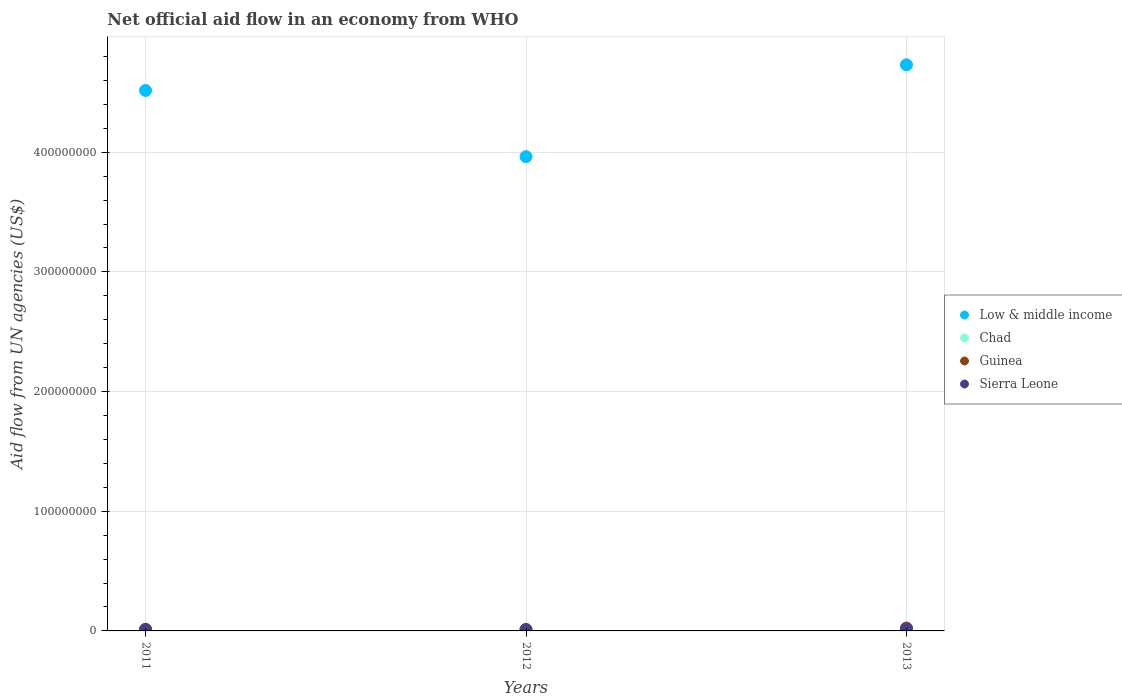Is the number of dotlines equal to the number of legend labels?
Make the answer very short. Yes. What is the net official aid flow in Chad in 2012?
Offer a very short reply. 1.04e+06. Across all years, what is the maximum net official aid flow in Chad?
Keep it short and to the point. 1.61e+06. Across all years, what is the minimum net official aid flow in Low & middle income?
Your answer should be very brief. 3.96e+08. In which year was the net official aid flow in Sierra Leone maximum?
Keep it short and to the point. 2013. In which year was the net official aid flow in Low & middle income minimum?
Keep it short and to the point. 2012. What is the total net official aid flow in Guinea in the graph?
Your response must be concise. 4.86e+06. What is the difference between the net official aid flow in Sierra Leone in 2012 and that in 2013?
Keep it short and to the point. -6.40e+05. What is the difference between the net official aid flow in Sierra Leone in 2011 and the net official aid flow in Low & middle income in 2012?
Make the answer very short. -3.95e+08. What is the average net official aid flow in Guinea per year?
Offer a very short reply. 1.62e+06. In the year 2012, what is the difference between the net official aid flow in Chad and net official aid flow in Guinea?
Keep it short and to the point. -2.30e+05. What is the ratio of the net official aid flow in Chad in 2011 to that in 2012?
Give a very brief answer. 1.51. Is the net official aid flow in Low & middle income in 2011 less than that in 2012?
Your answer should be compact. No. What is the difference between the highest and the lowest net official aid flow in Chad?
Your response must be concise. 5.70e+05. In how many years, is the net official aid flow in Guinea greater than the average net official aid flow in Guinea taken over all years?
Provide a short and direct response. 1. Is it the case that in every year, the sum of the net official aid flow in Sierra Leone and net official aid flow in Low & middle income  is greater than the sum of net official aid flow in Guinea and net official aid flow in Chad?
Give a very brief answer. Yes. Is it the case that in every year, the sum of the net official aid flow in Low & middle income and net official aid flow in Guinea  is greater than the net official aid flow in Sierra Leone?
Give a very brief answer. Yes. Does the net official aid flow in Chad monotonically increase over the years?
Offer a very short reply. No. Is the net official aid flow in Low & middle income strictly greater than the net official aid flow in Chad over the years?
Provide a short and direct response. Yes. Is the net official aid flow in Chad strictly less than the net official aid flow in Low & middle income over the years?
Your answer should be very brief. Yes. How many dotlines are there?
Your answer should be compact. 4. What is the difference between two consecutive major ticks on the Y-axis?
Offer a very short reply. 1.00e+08. Are the values on the major ticks of Y-axis written in scientific E-notation?
Your answer should be compact. No. How many legend labels are there?
Offer a terse response. 4. What is the title of the graph?
Provide a succinct answer. Net official aid flow in an economy from WHO. What is the label or title of the Y-axis?
Offer a very short reply. Aid flow from UN agencies (US$). What is the Aid flow from UN agencies (US$) in Low & middle income in 2011?
Offer a very short reply. 4.52e+08. What is the Aid flow from UN agencies (US$) in Chad in 2011?
Provide a short and direct response. 1.57e+06. What is the Aid flow from UN agencies (US$) in Guinea in 2011?
Provide a succinct answer. 1.17e+06. What is the Aid flow from UN agencies (US$) in Sierra Leone in 2011?
Make the answer very short. 1.19e+06. What is the Aid flow from UN agencies (US$) of Low & middle income in 2012?
Offer a very short reply. 3.96e+08. What is the Aid flow from UN agencies (US$) of Chad in 2012?
Your answer should be very brief. 1.04e+06. What is the Aid flow from UN agencies (US$) of Guinea in 2012?
Keep it short and to the point. 1.27e+06. What is the Aid flow from UN agencies (US$) of Sierra Leone in 2012?
Ensure brevity in your answer.  8.00e+05. What is the Aid flow from UN agencies (US$) in Low & middle income in 2013?
Give a very brief answer. 4.73e+08. What is the Aid flow from UN agencies (US$) of Chad in 2013?
Your answer should be very brief. 1.61e+06. What is the Aid flow from UN agencies (US$) in Guinea in 2013?
Offer a very short reply. 2.42e+06. What is the Aid flow from UN agencies (US$) in Sierra Leone in 2013?
Ensure brevity in your answer.  1.44e+06. Across all years, what is the maximum Aid flow from UN agencies (US$) of Low & middle income?
Offer a very short reply. 4.73e+08. Across all years, what is the maximum Aid flow from UN agencies (US$) in Chad?
Keep it short and to the point. 1.61e+06. Across all years, what is the maximum Aid flow from UN agencies (US$) of Guinea?
Keep it short and to the point. 2.42e+06. Across all years, what is the maximum Aid flow from UN agencies (US$) of Sierra Leone?
Keep it short and to the point. 1.44e+06. Across all years, what is the minimum Aid flow from UN agencies (US$) of Low & middle income?
Keep it short and to the point. 3.96e+08. Across all years, what is the minimum Aid flow from UN agencies (US$) of Chad?
Your answer should be compact. 1.04e+06. Across all years, what is the minimum Aid flow from UN agencies (US$) in Guinea?
Ensure brevity in your answer.  1.17e+06. Across all years, what is the minimum Aid flow from UN agencies (US$) of Sierra Leone?
Provide a succinct answer. 8.00e+05. What is the total Aid flow from UN agencies (US$) of Low & middle income in the graph?
Provide a short and direct response. 1.32e+09. What is the total Aid flow from UN agencies (US$) of Chad in the graph?
Provide a short and direct response. 4.22e+06. What is the total Aid flow from UN agencies (US$) in Guinea in the graph?
Provide a short and direct response. 4.86e+06. What is the total Aid flow from UN agencies (US$) of Sierra Leone in the graph?
Ensure brevity in your answer.  3.43e+06. What is the difference between the Aid flow from UN agencies (US$) of Low & middle income in 2011 and that in 2012?
Your response must be concise. 5.53e+07. What is the difference between the Aid flow from UN agencies (US$) of Chad in 2011 and that in 2012?
Your response must be concise. 5.30e+05. What is the difference between the Aid flow from UN agencies (US$) in Guinea in 2011 and that in 2012?
Provide a short and direct response. -1.00e+05. What is the difference between the Aid flow from UN agencies (US$) in Sierra Leone in 2011 and that in 2012?
Offer a terse response. 3.90e+05. What is the difference between the Aid flow from UN agencies (US$) in Low & middle income in 2011 and that in 2013?
Offer a terse response. -2.14e+07. What is the difference between the Aid flow from UN agencies (US$) of Chad in 2011 and that in 2013?
Your response must be concise. -4.00e+04. What is the difference between the Aid flow from UN agencies (US$) of Guinea in 2011 and that in 2013?
Your answer should be very brief. -1.25e+06. What is the difference between the Aid flow from UN agencies (US$) of Sierra Leone in 2011 and that in 2013?
Provide a succinct answer. -2.50e+05. What is the difference between the Aid flow from UN agencies (US$) of Low & middle income in 2012 and that in 2013?
Make the answer very short. -7.67e+07. What is the difference between the Aid flow from UN agencies (US$) in Chad in 2012 and that in 2013?
Make the answer very short. -5.70e+05. What is the difference between the Aid flow from UN agencies (US$) in Guinea in 2012 and that in 2013?
Provide a short and direct response. -1.15e+06. What is the difference between the Aid flow from UN agencies (US$) of Sierra Leone in 2012 and that in 2013?
Provide a succinct answer. -6.40e+05. What is the difference between the Aid flow from UN agencies (US$) of Low & middle income in 2011 and the Aid flow from UN agencies (US$) of Chad in 2012?
Offer a very short reply. 4.51e+08. What is the difference between the Aid flow from UN agencies (US$) in Low & middle income in 2011 and the Aid flow from UN agencies (US$) in Guinea in 2012?
Provide a short and direct response. 4.50e+08. What is the difference between the Aid flow from UN agencies (US$) of Low & middle income in 2011 and the Aid flow from UN agencies (US$) of Sierra Leone in 2012?
Ensure brevity in your answer.  4.51e+08. What is the difference between the Aid flow from UN agencies (US$) of Chad in 2011 and the Aid flow from UN agencies (US$) of Guinea in 2012?
Offer a terse response. 3.00e+05. What is the difference between the Aid flow from UN agencies (US$) in Chad in 2011 and the Aid flow from UN agencies (US$) in Sierra Leone in 2012?
Your response must be concise. 7.70e+05. What is the difference between the Aid flow from UN agencies (US$) of Low & middle income in 2011 and the Aid flow from UN agencies (US$) of Chad in 2013?
Provide a succinct answer. 4.50e+08. What is the difference between the Aid flow from UN agencies (US$) of Low & middle income in 2011 and the Aid flow from UN agencies (US$) of Guinea in 2013?
Offer a terse response. 4.49e+08. What is the difference between the Aid flow from UN agencies (US$) of Low & middle income in 2011 and the Aid flow from UN agencies (US$) of Sierra Leone in 2013?
Give a very brief answer. 4.50e+08. What is the difference between the Aid flow from UN agencies (US$) of Chad in 2011 and the Aid flow from UN agencies (US$) of Guinea in 2013?
Your answer should be very brief. -8.50e+05. What is the difference between the Aid flow from UN agencies (US$) in Chad in 2011 and the Aid flow from UN agencies (US$) in Sierra Leone in 2013?
Your answer should be very brief. 1.30e+05. What is the difference between the Aid flow from UN agencies (US$) of Guinea in 2011 and the Aid flow from UN agencies (US$) of Sierra Leone in 2013?
Give a very brief answer. -2.70e+05. What is the difference between the Aid flow from UN agencies (US$) in Low & middle income in 2012 and the Aid flow from UN agencies (US$) in Chad in 2013?
Offer a very short reply. 3.95e+08. What is the difference between the Aid flow from UN agencies (US$) in Low & middle income in 2012 and the Aid flow from UN agencies (US$) in Guinea in 2013?
Provide a short and direct response. 3.94e+08. What is the difference between the Aid flow from UN agencies (US$) of Low & middle income in 2012 and the Aid flow from UN agencies (US$) of Sierra Leone in 2013?
Ensure brevity in your answer.  3.95e+08. What is the difference between the Aid flow from UN agencies (US$) in Chad in 2012 and the Aid flow from UN agencies (US$) in Guinea in 2013?
Keep it short and to the point. -1.38e+06. What is the difference between the Aid flow from UN agencies (US$) in Chad in 2012 and the Aid flow from UN agencies (US$) in Sierra Leone in 2013?
Ensure brevity in your answer.  -4.00e+05. What is the difference between the Aid flow from UN agencies (US$) of Guinea in 2012 and the Aid flow from UN agencies (US$) of Sierra Leone in 2013?
Your answer should be very brief. -1.70e+05. What is the average Aid flow from UN agencies (US$) in Low & middle income per year?
Your answer should be very brief. 4.40e+08. What is the average Aid flow from UN agencies (US$) in Chad per year?
Make the answer very short. 1.41e+06. What is the average Aid flow from UN agencies (US$) in Guinea per year?
Offer a very short reply. 1.62e+06. What is the average Aid flow from UN agencies (US$) in Sierra Leone per year?
Your answer should be very brief. 1.14e+06. In the year 2011, what is the difference between the Aid flow from UN agencies (US$) in Low & middle income and Aid flow from UN agencies (US$) in Chad?
Your response must be concise. 4.50e+08. In the year 2011, what is the difference between the Aid flow from UN agencies (US$) in Low & middle income and Aid flow from UN agencies (US$) in Guinea?
Ensure brevity in your answer.  4.50e+08. In the year 2011, what is the difference between the Aid flow from UN agencies (US$) in Low & middle income and Aid flow from UN agencies (US$) in Sierra Leone?
Keep it short and to the point. 4.50e+08. In the year 2011, what is the difference between the Aid flow from UN agencies (US$) in Chad and Aid flow from UN agencies (US$) in Guinea?
Your answer should be compact. 4.00e+05. In the year 2012, what is the difference between the Aid flow from UN agencies (US$) in Low & middle income and Aid flow from UN agencies (US$) in Chad?
Offer a very short reply. 3.95e+08. In the year 2012, what is the difference between the Aid flow from UN agencies (US$) in Low & middle income and Aid flow from UN agencies (US$) in Guinea?
Ensure brevity in your answer.  3.95e+08. In the year 2012, what is the difference between the Aid flow from UN agencies (US$) in Low & middle income and Aid flow from UN agencies (US$) in Sierra Leone?
Your answer should be compact. 3.95e+08. In the year 2012, what is the difference between the Aid flow from UN agencies (US$) of Guinea and Aid flow from UN agencies (US$) of Sierra Leone?
Ensure brevity in your answer.  4.70e+05. In the year 2013, what is the difference between the Aid flow from UN agencies (US$) in Low & middle income and Aid flow from UN agencies (US$) in Chad?
Provide a short and direct response. 4.71e+08. In the year 2013, what is the difference between the Aid flow from UN agencies (US$) of Low & middle income and Aid flow from UN agencies (US$) of Guinea?
Provide a succinct answer. 4.71e+08. In the year 2013, what is the difference between the Aid flow from UN agencies (US$) of Low & middle income and Aid flow from UN agencies (US$) of Sierra Leone?
Make the answer very short. 4.72e+08. In the year 2013, what is the difference between the Aid flow from UN agencies (US$) of Chad and Aid flow from UN agencies (US$) of Guinea?
Ensure brevity in your answer.  -8.10e+05. In the year 2013, what is the difference between the Aid flow from UN agencies (US$) in Guinea and Aid flow from UN agencies (US$) in Sierra Leone?
Provide a short and direct response. 9.80e+05. What is the ratio of the Aid flow from UN agencies (US$) of Low & middle income in 2011 to that in 2012?
Ensure brevity in your answer.  1.14. What is the ratio of the Aid flow from UN agencies (US$) in Chad in 2011 to that in 2012?
Offer a terse response. 1.51. What is the ratio of the Aid flow from UN agencies (US$) in Guinea in 2011 to that in 2012?
Keep it short and to the point. 0.92. What is the ratio of the Aid flow from UN agencies (US$) in Sierra Leone in 2011 to that in 2012?
Make the answer very short. 1.49. What is the ratio of the Aid flow from UN agencies (US$) of Low & middle income in 2011 to that in 2013?
Offer a terse response. 0.95. What is the ratio of the Aid flow from UN agencies (US$) in Chad in 2011 to that in 2013?
Give a very brief answer. 0.98. What is the ratio of the Aid flow from UN agencies (US$) in Guinea in 2011 to that in 2013?
Your answer should be very brief. 0.48. What is the ratio of the Aid flow from UN agencies (US$) in Sierra Leone in 2011 to that in 2013?
Keep it short and to the point. 0.83. What is the ratio of the Aid flow from UN agencies (US$) of Low & middle income in 2012 to that in 2013?
Your response must be concise. 0.84. What is the ratio of the Aid flow from UN agencies (US$) of Chad in 2012 to that in 2013?
Your answer should be compact. 0.65. What is the ratio of the Aid flow from UN agencies (US$) in Guinea in 2012 to that in 2013?
Your answer should be compact. 0.52. What is the ratio of the Aid flow from UN agencies (US$) in Sierra Leone in 2012 to that in 2013?
Provide a succinct answer. 0.56. What is the difference between the highest and the second highest Aid flow from UN agencies (US$) in Low & middle income?
Your answer should be compact. 2.14e+07. What is the difference between the highest and the second highest Aid flow from UN agencies (US$) in Guinea?
Keep it short and to the point. 1.15e+06. What is the difference between the highest and the lowest Aid flow from UN agencies (US$) in Low & middle income?
Make the answer very short. 7.67e+07. What is the difference between the highest and the lowest Aid flow from UN agencies (US$) of Chad?
Offer a very short reply. 5.70e+05. What is the difference between the highest and the lowest Aid flow from UN agencies (US$) in Guinea?
Keep it short and to the point. 1.25e+06. What is the difference between the highest and the lowest Aid flow from UN agencies (US$) in Sierra Leone?
Your response must be concise. 6.40e+05. 